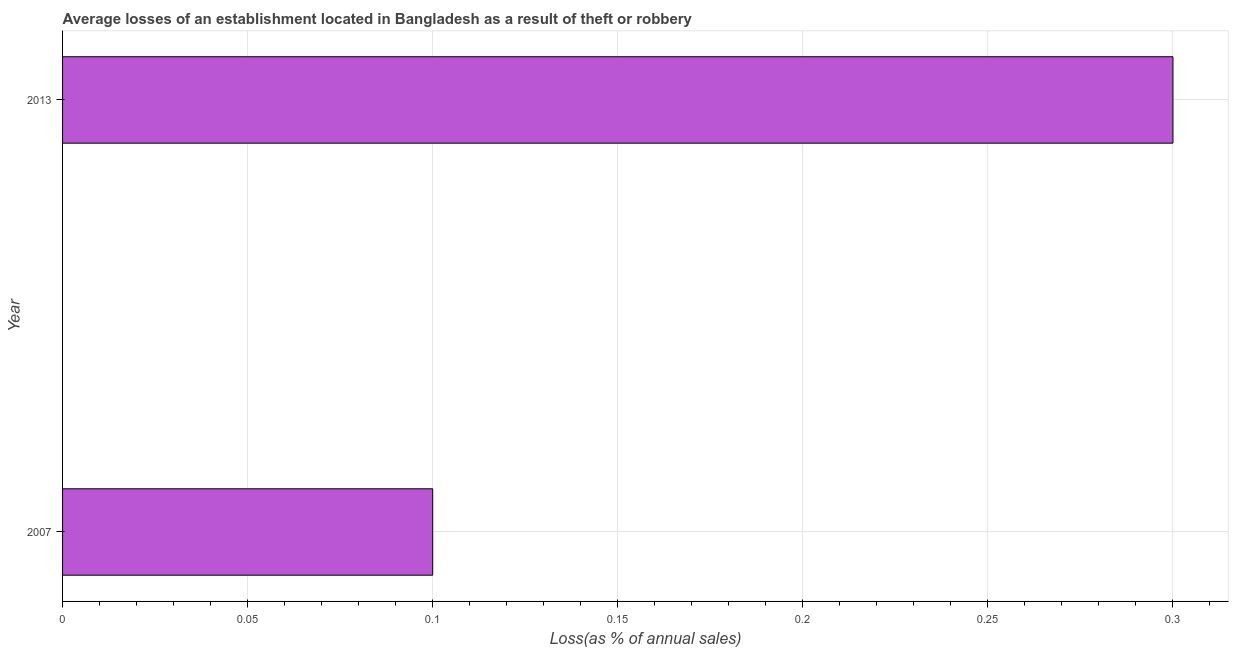What is the title of the graph?
Provide a succinct answer. Average losses of an establishment located in Bangladesh as a result of theft or robbery. What is the label or title of the X-axis?
Make the answer very short. Loss(as % of annual sales). Across all years, what is the maximum losses due to theft?
Ensure brevity in your answer.  0.3. Across all years, what is the minimum losses due to theft?
Your answer should be compact. 0.1. In which year was the losses due to theft maximum?
Your answer should be very brief. 2013. What is the average losses due to theft per year?
Offer a very short reply. 0.2. What is the ratio of the losses due to theft in 2007 to that in 2013?
Provide a succinct answer. 0.33. Is the losses due to theft in 2007 less than that in 2013?
Provide a succinct answer. Yes. How many bars are there?
Ensure brevity in your answer.  2. How many years are there in the graph?
Offer a terse response. 2. What is the difference between two consecutive major ticks on the X-axis?
Provide a short and direct response. 0.05. What is the Loss(as % of annual sales) of 2007?
Offer a terse response. 0.1. What is the ratio of the Loss(as % of annual sales) in 2007 to that in 2013?
Your answer should be compact. 0.33. 